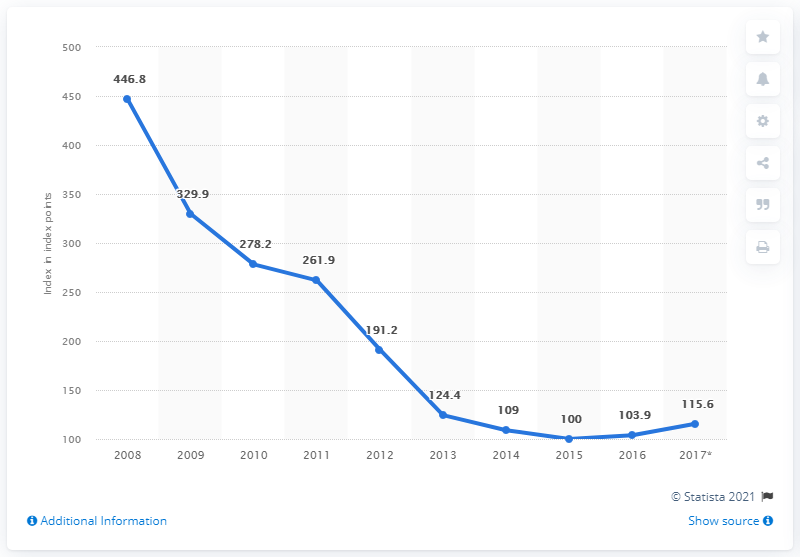List a handful of essential elements in this visual. The graph is decreasing. Of the years with a value below 100, how many do we have? 